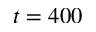Convert formula to latex. <formula><loc_0><loc_0><loc_500><loc_500>t = 4 0 0</formula> 